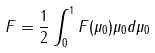<formula> <loc_0><loc_0><loc_500><loc_500>F = \frac { 1 } { 2 } \int _ { 0 } ^ { 1 } F ( \mu _ { 0 } ) \mu _ { 0 } d \mu _ { 0 }</formula> 